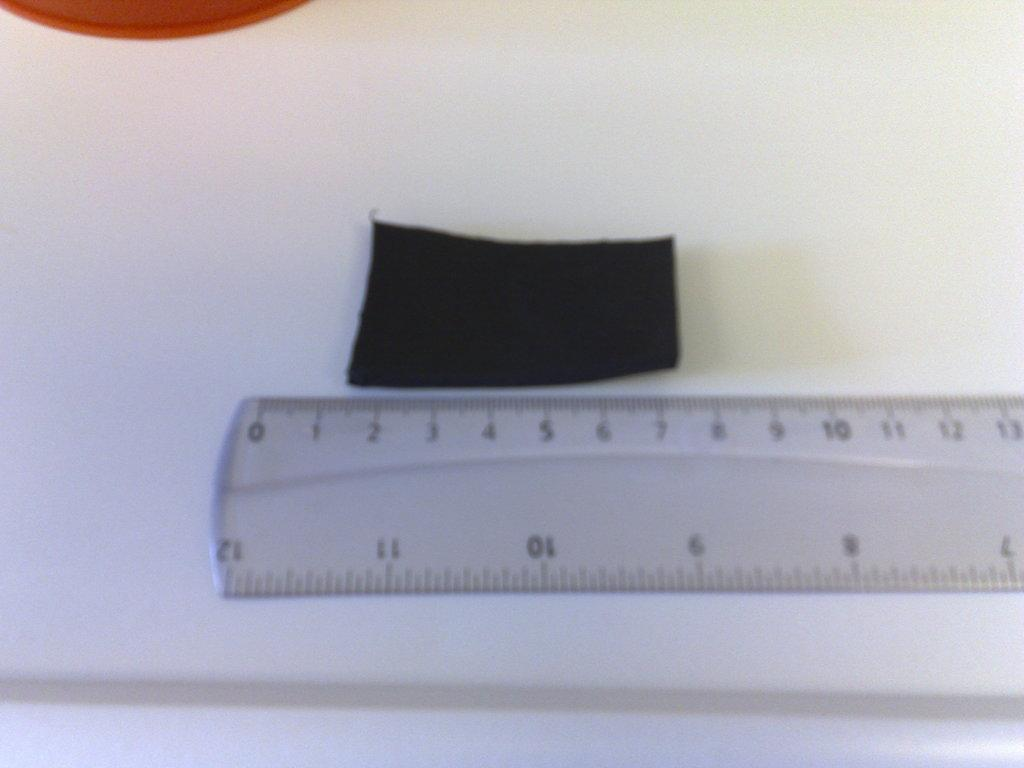<image>
Share a concise interpretation of the image provided. A black rectangle being measured on the cm side of a ruler between 1 and 7. 